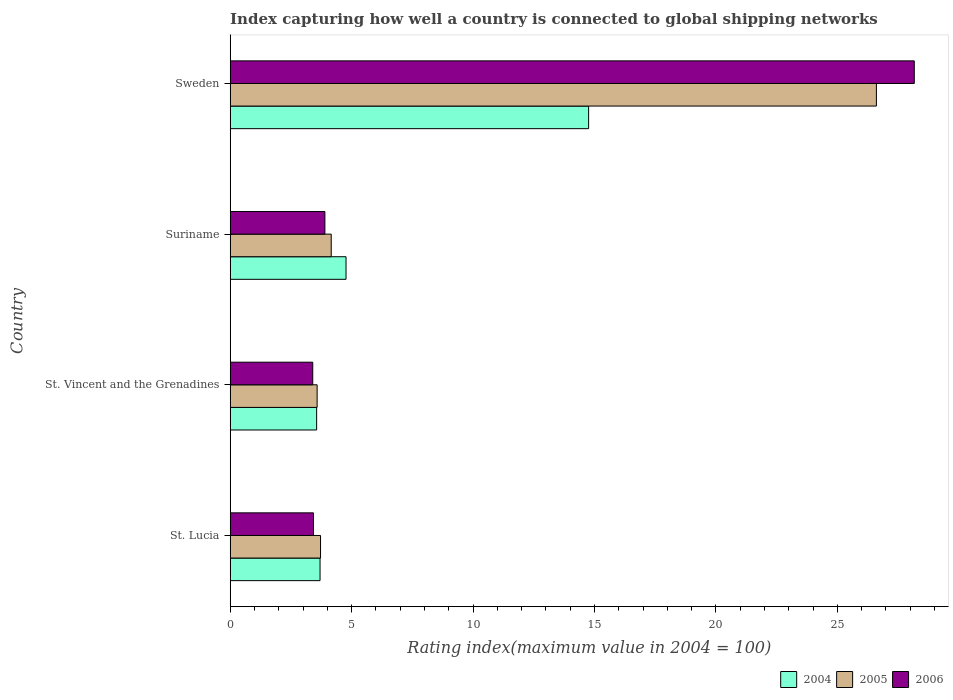Are the number of bars per tick equal to the number of legend labels?
Your answer should be compact. Yes. How many bars are there on the 3rd tick from the bottom?
Keep it short and to the point. 3. What is the label of the 2nd group of bars from the top?
Your answer should be very brief. Suriname. In how many cases, is the number of bars for a given country not equal to the number of legend labels?
Ensure brevity in your answer.  0. What is the rating index in 2004 in St. Vincent and the Grenadines?
Give a very brief answer. 3.56. Across all countries, what is the maximum rating index in 2006?
Make the answer very short. 28.17. Across all countries, what is the minimum rating index in 2004?
Provide a short and direct response. 3.56. In which country was the rating index in 2005 minimum?
Your response must be concise. St. Vincent and the Grenadines. What is the total rating index in 2005 in the graph?
Your answer should be compact. 38.07. What is the difference between the rating index in 2006 in St. Vincent and the Grenadines and the rating index in 2004 in Sweden?
Your answer should be compact. -11.36. What is the average rating index in 2004 per country?
Your answer should be very brief. 6.7. What is the difference between the rating index in 2005 and rating index in 2004 in St. Lucia?
Give a very brief answer. 0.02. In how many countries, is the rating index in 2006 greater than 28 ?
Give a very brief answer. 1. What is the ratio of the rating index in 2006 in St. Vincent and the Grenadines to that in Suriname?
Keep it short and to the point. 0.87. What is the difference between the highest and the second highest rating index in 2005?
Give a very brief answer. 22.45. What is the difference between the highest and the lowest rating index in 2005?
Keep it short and to the point. 23.03. Is it the case that in every country, the sum of the rating index in 2006 and rating index in 2004 is greater than the rating index in 2005?
Provide a short and direct response. Yes. How many bars are there?
Your answer should be compact. 12. Are the values on the major ticks of X-axis written in scientific E-notation?
Offer a terse response. No. Does the graph contain any zero values?
Your answer should be compact. No. Where does the legend appear in the graph?
Ensure brevity in your answer.  Bottom right. How are the legend labels stacked?
Ensure brevity in your answer.  Horizontal. What is the title of the graph?
Your answer should be very brief. Index capturing how well a country is connected to global shipping networks. Does "1990" appear as one of the legend labels in the graph?
Offer a very short reply. No. What is the label or title of the X-axis?
Your answer should be very brief. Rating index(maximum value in 2004 = 100). What is the Rating index(maximum value in 2004 = 100) of 2004 in St. Lucia?
Offer a very short reply. 3.7. What is the Rating index(maximum value in 2004 = 100) in 2005 in St. Lucia?
Give a very brief answer. 3.72. What is the Rating index(maximum value in 2004 = 100) of 2006 in St. Lucia?
Offer a terse response. 3.43. What is the Rating index(maximum value in 2004 = 100) of 2004 in St. Vincent and the Grenadines?
Ensure brevity in your answer.  3.56. What is the Rating index(maximum value in 2004 = 100) of 2005 in St. Vincent and the Grenadines?
Provide a succinct answer. 3.58. What is the Rating index(maximum value in 2004 = 100) in 2004 in Suriname?
Ensure brevity in your answer.  4.77. What is the Rating index(maximum value in 2004 = 100) of 2005 in Suriname?
Offer a terse response. 4.16. What is the Rating index(maximum value in 2004 = 100) of 2004 in Sweden?
Your response must be concise. 14.76. What is the Rating index(maximum value in 2004 = 100) in 2005 in Sweden?
Your response must be concise. 26.61. What is the Rating index(maximum value in 2004 = 100) of 2006 in Sweden?
Provide a short and direct response. 28.17. Across all countries, what is the maximum Rating index(maximum value in 2004 = 100) in 2004?
Offer a very short reply. 14.76. Across all countries, what is the maximum Rating index(maximum value in 2004 = 100) of 2005?
Your response must be concise. 26.61. Across all countries, what is the maximum Rating index(maximum value in 2004 = 100) of 2006?
Your response must be concise. 28.17. Across all countries, what is the minimum Rating index(maximum value in 2004 = 100) in 2004?
Make the answer very short. 3.56. Across all countries, what is the minimum Rating index(maximum value in 2004 = 100) in 2005?
Keep it short and to the point. 3.58. Across all countries, what is the minimum Rating index(maximum value in 2004 = 100) of 2006?
Your response must be concise. 3.4. What is the total Rating index(maximum value in 2004 = 100) in 2004 in the graph?
Keep it short and to the point. 26.79. What is the total Rating index(maximum value in 2004 = 100) in 2005 in the graph?
Keep it short and to the point. 38.07. What is the total Rating index(maximum value in 2004 = 100) in 2006 in the graph?
Your answer should be very brief. 38.9. What is the difference between the Rating index(maximum value in 2004 = 100) in 2004 in St. Lucia and that in St. Vincent and the Grenadines?
Your answer should be compact. 0.14. What is the difference between the Rating index(maximum value in 2004 = 100) in 2005 in St. Lucia and that in St. Vincent and the Grenadines?
Your answer should be very brief. 0.14. What is the difference between the Rating index(maximum value in 2004 = 100) in 2004 in St. Lucia and that in Suriname?
Offer a terse response. -1.07. What is the difference between the Rating index(maximum value in 2004 = 100) of 2005 in St. Lucia and that in Suriname?
Provide a succinct answer. -0.44. What is the difference between the Rating index(maximum value in 2004 = 100) in 2006 in St. Lucia and that in Suriname?
Your answer should be compact. -0.47. What is the difference between the Rating index(maximum value in 2004 = 100) in 2004 in St. Lucia and that in Sweden?
Provide a short and direct response. -11.06. What is the difference between the Rating index(maximum value in 2004 = 100) in 2005 in St. Lucia and that in Sweden?
Your response must be concise. -22.89. What is the difference between the Rating index(maximum value in 2004 = 100) in 2006 in St. Lucia and that in Sweden?
Ensure brevity in your answer.  -24.74. What is the difference between the Rating index(maximum value in 2004 = 100) in 2004 in St. Vincent and the Grenadines and that in Suriname?
Offer a terse response. -1.21. What is the difference between the Rating index(maximum value in 2004 = 100) in 2005 in St. Vincent and the Grenadines and that in Suriname?
Give a very brief answer. -0.58. What is the difference between the Rating index(maximum value in 2004 = 100) in 2004 in St. Vincent and the Grenadines and that in Sweden?
Provide a short and direct response. -11.2. What is the difference between the Rating index(maximum value in 2004 = 100) in 2005 in St. Vincent and the Grenadines and that in Sweden?
Your response must be concise. -23.03. What is the difference between the Rating index(maximum value in 2004 = 100) in 2006 in St. Vincent and the Grenadines and that in Sweden?
Keep it short and to the point. -24.77. What is the difference between the Rating index(maximum value in 2004 = 100) in 2004 in Suriname and that in Sweden?
Ensure brevity in your answer.  -9.99. What is the difference between the Rating index(maximum value in 2004 = 100) in 2005 in Suriname and that in Sweden?
Offer a very short reply. -22.45. What is the difference between the Rating index(maximum value in 2004 = 100) in 2006 in Suriname and that in Sweden?
Your answer should be very brief. -24.27. What is the difference between the Rating index(maximum value in 2004 = 100) of 2004 in St. Lucia and the Rating index(maximum value in 2004 = 100) of 2005 in St. Vincent and the Grenadines?
Provide a succinct answer. 0.12. What is the difference between the Rating index(maximum value in 2004 = 100) of 2004 in St. Lucia and the Rating index(maximum value in 2004 = 100) of 2006 in St. Vincent and the Grenadines?
Your answer should be compact. 0.3. What is the difference between the Rating index(maximum value in 2004 = 100) of 2005 in St. Lucia and the Rating index(maximum value in 2004 = 100) of 2006 in St. Vincent and the Grenadines?
Your answer should be very brief. 0.32. What is the difference between the Rating index(maximum value in 2004 = 100) in 2004 in St. Lucia and the Rating index(maximum value in 2004 = 100) in 2005 in Suriname?
Offer a very short reply. -0.46. What is the difference between the Rating index(maximum value in 2004 = 100) in 2005 in St. Lucia and the Rating index(maximum value in 2004 = 100) in 2006 in Suriname?
Offer a terse response. -0.18. What is the difference between the Rating index(maximum value in 2004 = 100) in 2004 in St. Lucia and the Rating index(maximum value in 2004 = 100) in 2005 in Sweden?
Keep it short and to the point. -22.91. What is the difference between the Rating index(maximum value in 2004 = 100) of 2004 in St. Lucia and the Rating index(maximum value in 2004 = 100) of 2006 in Sweden?
Make the answer very short. -24.47. What is the difference between the Rating index(maximum value in 2004 = 100) of 2005 in St. Lucia and the Rating index(maximum value in 2004 = 100) of 2006 in Sweden?
Your answer should be very brief. -24.45. What is the difference between the Rating index(maximum value in 2004 = 100) of 2004 in St. Vincent and the Grenadines and the Rating index(maximum value in 2004 = 100) of 2006 in Suriname?
Offer a terse response. -0.34. What is the difference between the Rating index(maximum value in 2004 = 100) of 2005 in St. Vincent and the Grenadines and the Rating index(maximum value in 2004 = 100) of 2006 in Suriname?
Your response must be concise. -0.32. What is the difference between the Rating index(maximum value in 2004 = 100) of 2004 in St. Vincent and the Grenadines and the Rating index(maximum value in 2004 = 100) of 2005 in Sweden?
Keep it short and to the point. -23.05. What is the difference between the Rating index(maximum value in 2004 = 100) of 2004 in St. Vincent and the Grenadines and the Rating index(maximum value in 2004 = 100) of 2006 in Sweden?
Your answer should be very brief. -24.61. What is the difference between the Rating index(maximum value in 2004 = 100) in 2005 in St. Vincent and the Grenadines and the Rating index(maximum value in 2004 = 100) in 2006 in Sweden?
Ensure brevity in your answer.  -24.59. What is the difference between the Rating index(maximum value in 2004 = 100) in 2004 in Suriname and the Rating index(maximum value in 2004 = 100) in 2005 in Sweden?
Offer a terse response. -21.84. What is the difference between the Rating index(maximum value in 2004 = 100) in 2004 in Suriname and the Rating index(maximum value in 2004 = 100) in 2006 in Sweden?
Your answer should be compact. -23.4. What is the difference between the Rating index(maximum value in 2004 = 100) in 2005 in Suriname and the Rating index(maximum value in 2004 = 100) in 2006 in Sweden?
Make the answer very short. -24.01. What is the average Rating index(maximum value in 2004 = 100) of 2004 per country?
Your answer should be very brief. 6.7. What is the average Rating index(maximum value in 2004 = 100) of 2005 per country?
Your answer should be compact. 9.52. What is the average Rating index(maximum value in 2004 = 100) of 2006 per country?
Your answer should be compact. 9.72. What is the difference between the Rating index(maximum value in 2004 = 100) of 2004 and Rating index(maximum value in 2004 = 100) of 2005 in St. Lucia?
Your answer should be compact. -0.02. What is the difference between the Rating index(maximum value in 2004 = 100) of 2004 and Rating index(maximum value in 2004 = 100) of 2006 in St. Lucia?
Make the answer very short. 0.27. What is the difference between the Rating index(maximum value in 2004 = 100) of 2005 and Rating index(maximum value in 2004 = 100) of 2006 in St. Lucia?
Your answer should be very brief. 0.29. What is the difference between the Rating index(maximum value in 2004 = 100) of 2004 and Rating index(maximum value in 2004 = 100) of 2005 in St. Vincent and the Grenadines?
Provide a succinct answer. -0.02. What is the difference between the Rating index(maximum value in 2004 = 100) of 2004 and Rating index(maximum value in 2004 = 100) of 2006 in St. Vincent and the Grenadines?
Give a very brief answer. 0.16. What is the difference between the Rating index(maximum value in 2004 = 100) of 2005 and Rating index(maximum value in 2004 = 100) of 2006 in St. Vincent and the Grenadines?
Offer a terse response. 0.18. What is the difference between the Rating index(maximum value in 2004 = 100) of 2004 and Rating index(maximum value in 2004 = 100) of 2005 in Suriname?
Your answer should be compact. 0.61. What is the difference between the Rating index(maximum value in 2004 = 100) of 2004 and Rating index(maximum value in 2004 = 100) of 2006 in Suriname?
Offer a terse response. 0.87. What is the difference between the Rating index(maximum value in 2004 = 100) of 2005 and Rating index(maximum value in 2004 = 100) of 2006 in Suriname?
Give a very brief answer. 0.26. What is the difference between the Rating index(maximum value in 2004 = 100) of 2004 and Rating index(maximum value in 2004 = 100) of 2005 in Sweden?
Your answer should be very brief. -11.85. What is the difference between the Rating index(maximum value in 2004 = 100) in 2004 and Rating index(maximum value in 2004 = 100) in 2006 in Sweden?
Keep it short and to the point. -13.41. What is the difference between the Rating index(maximum value in 2004 = 100) of 2005 and Rating index(maximum value in 2004 = 100) of 2006 in Sweden?
Your answer should be compact. -1.56. What is the ratio of the Rating index(maximum value in 2004 = 100) of 2004 in St. Lucia to that in St. Vincent and the Grenadines?
Your answer should be very brief. 1.04. What is the ratio of the Rating index(maximum value in 2004 = 100) of 2005 in St. Lucia to that in St. Vincent and the Grenadines?
Your answer should be compact. 1.04. What is the ratio of the Rating index(maximum value in 2004 = 100) in 2006 in St. Lucia to that in St. Vincent and the Grenadines?
Offer a very short reply. 1.01. What is the ratio of the Rating index(maximum value in 2004 = 100) in 2004 in St. Lucia to that in Suriname?
Provide a short and direct response. 0.78. What is the ratio of the Rating index(maximum value in 2004 = 100) of 2005 in St. Lucia to that in Suriname?
Your answer should be compact. 0.89. What is the ratio of the Rating index(maximum value in 2004 = 100) in 2006 in St. Lucia to that in Suriname?
Your answer should be very brief. 0.88. What is the ratio of the Rating index(maximum value in 2004 = 100) of 2004 in St. Lucia to that in Sweden?
Give a very brief answer. 0.25. What is the ratio of the Rating index(maximum value in 2004 = 100) of 2005 in St. Lucia to that in Sweden?
Provide a succinct answer. 0.14. What is the ratio of the Rating index(maximum value in 2004 = 100) of 2006 in St. Lucia to that in Sweden?
Give a very brief answer. 0.12. What is the ratio of the Rating index(maximum value in 2004 = 100) of 2004 in St. Vincent and the Grenadines to that in Suriname?
Offer a very short reply. 0.75. What is the ratio of the Rating index(maximum value in 2004 = 100) of 2005 in St. Vincent and the Grenadines to that in Suriname?
Provide a short and direct response. 0.86. What is the ratio of the Rating index(maximum value in 2004 = 100) in 2006 in St. Vincent and the Grenadines to that in Suriname?
Your answer should be very brief. 0.87. What is the ratio of the Rating index(maximum value in 2004 = 100) of 2004 in St. Vincent and the Grenadines to that in Sweden?
Offer a very short reply. 0.24. What is the ratio of the Rating index(maximum value in 2004 = 100) in 2005 in St. Vincent and the Grenadines to that in Sweden?
Keep it short and to the point. 0.13. What is the ratio of the Rating index(maximum value in 2004 = 100) of 2006 in St. Vincent and the Grenadines to that in Sweden?
Offer a terse response. 0.12. What is the ratio of the Rating index(maximum value in 2004 = 100) of 2004 in Suriname to that in Sweden?
Give a very brief answer. 0.32. What is the ratio of the Rating index(maximum value in 2004 = 100) in 2005 in Suriname to that in Sweden?
Keep it short and to the point. 0.16. What is the ratio of the Rating index(maximum value in 2004 = 100) in 2006 in Suriname to that in Sweden?
Provide a succinct answer. 0.14. What is the difference between the highest and the second highest Rating index(maximum value in 2004 = 100) of 2004?
Make the answer very short. 9.99. What is the difference between the highest and the second highest Rating index(maximum value in 2004 = 100) of 2005?
Make the answer very short. 22.45. What is the difference between the highest and the second highest Rating index(maximum value in 2004 = 100) of 2006?
Make the answer very short. 24.27. What is the difference between the highest and the lowest Rating index(maximum value in 2004 = 100) in 2005?
Provide a short and direct response. 23.03. What is the difference between the highest and the lowest Rating index(maximum value in 2004 = 100) in 2006?
Make the answer very short. 24.77. 